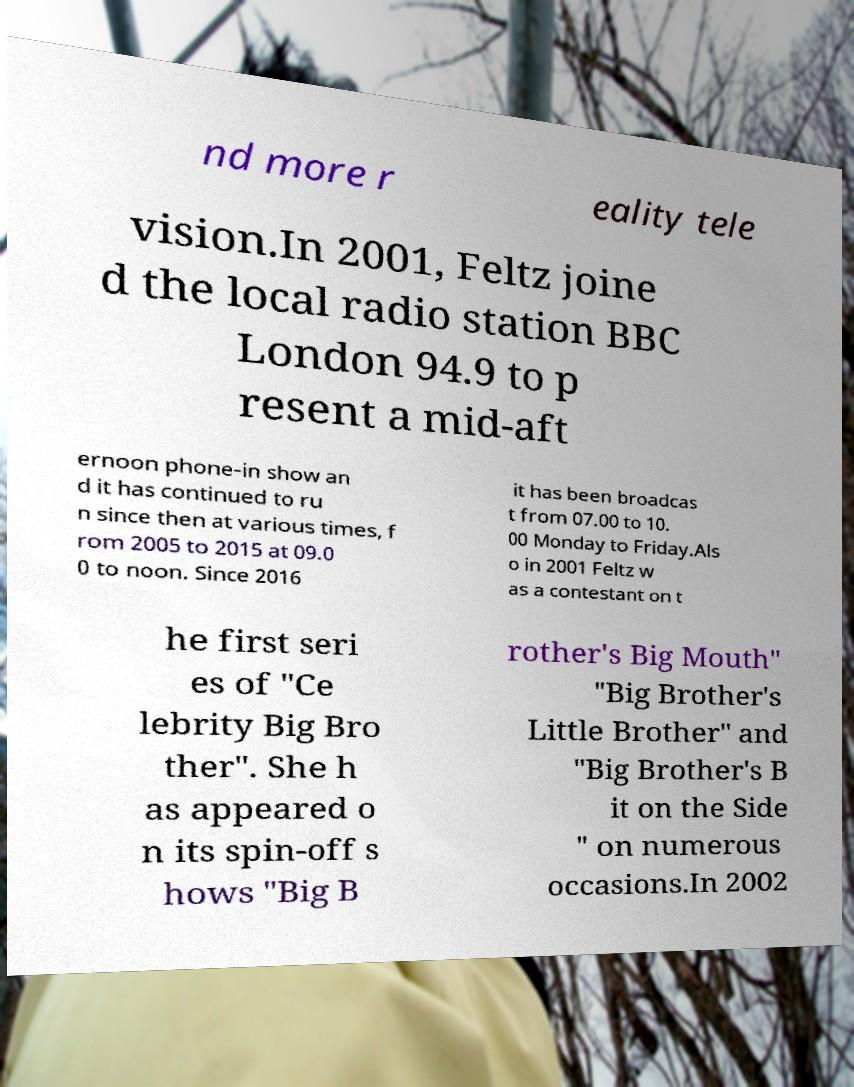What messages or text are displayed in this image? I need them in a readable, typed format. nd more r eality tele vision.In 2001, Feltz joine d the local radio station BBC London 94.9 to p resent a mid-aft ernoon phone-in show an d it has continued to ru n since then at various times, f rom 2005 to 2015 at 09.0 0 to noon. Since 2016 it has been broadcas t from 07.00 to 10. 00 Monday to Friday.Als o in 2001 Feltz w as a contestant on t he first seri es of "Ce lebrity Big Bro ther". She h as appeared o n its spin-off s hows "Big B rother's Big Mouth" "Big Brother's Little Brother" and "Big Brother's B it on the Side " on numerous occasions.In 2002 